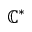Convert formula to latex. <formula><loc_0><loc_0><loc_500><loc_500>\mathbb { C } ^ { * }</formula> 